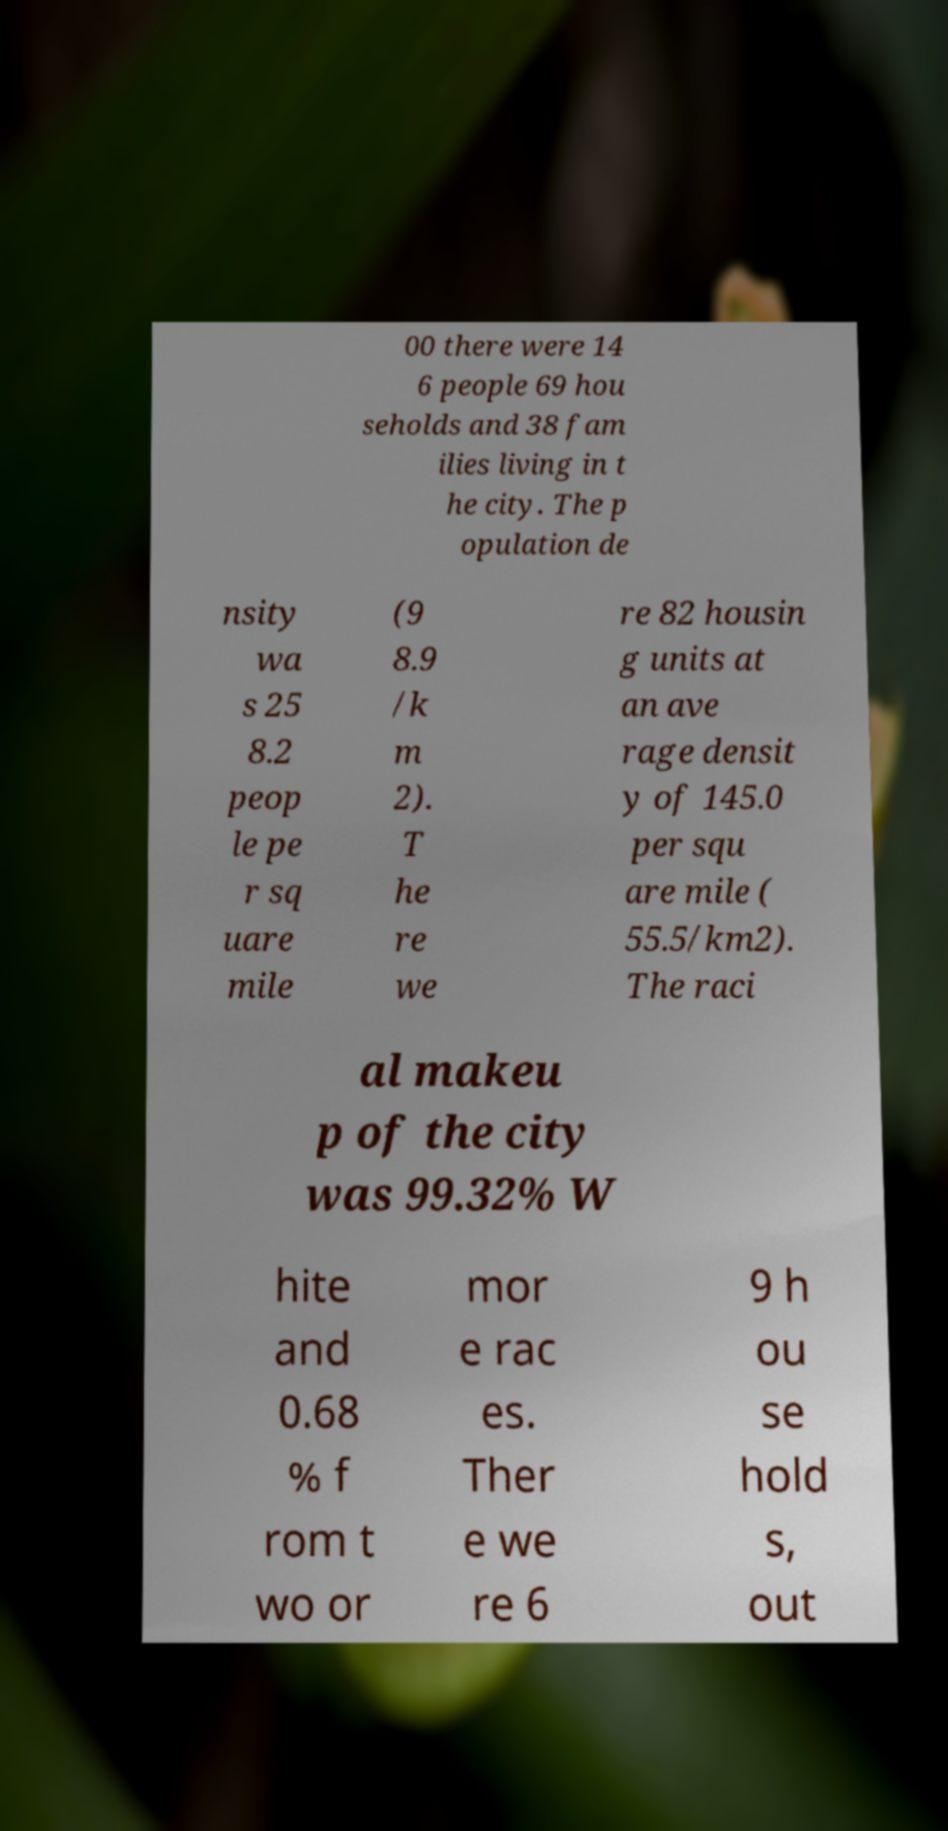There's text embedded in this image that I need extracted. Can you transcribe it verbatim? 00 there were 14 6 people 69 hou seholds and 38 fam ilies living in t he city. The p opulation de nsity wa s 25 8.2 peop le pe r sq uare mile (9 8.9 /k m 2). T he re we re 82 housin g units at an ave rage densit y of 145.0 per squ are mile ( 55.5/km2). The raci al makeu p of the city was 99.32% W hite and 0.68 % f rom t wo or mor e rac es. Ther e we re 6 9 h ou se hold s, out 